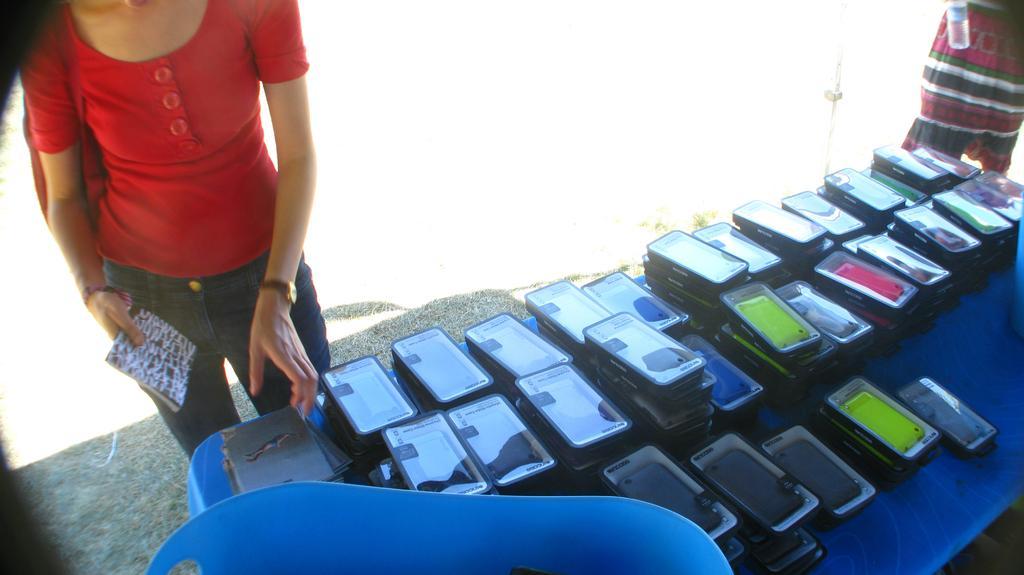In one or two sentences, can you explain what this image depicts? In this picture there is a woman who is wearing red t-shirt, trouser, bag and watch. She is standing near to the table. On the table I can see many phone back covers and other objects. On the top right corner there is a man who is holding a water bottle. 